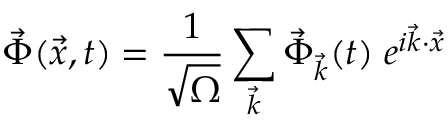Convert formula to latex. <formula><loc_0><loc_0><loc_500><loc_500>\vec { \Phi } ( \vec { x } , t ) = \frac { 1 } { \sqrt { \Omega } } \sum _ { \vec { k } } \vec { \Phi } _ { \vec { k } } ( t ) \, e ^ { i \vec { k } \cdot \vec { x } }</formula> 